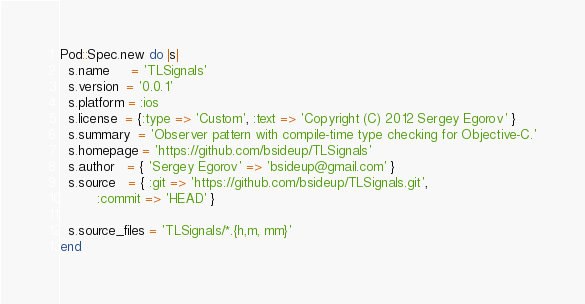<code> <loc_0><loc_0><loc_500><loc_500><_Ruby_>Pod::Spec.new do |s|
  s.name     = 'TLSignals'
  s.version  = '0.0.1'
  s.platform = :ios
  s.license  = {:type => 'Custom', :text => 'Copyright (C) 2012 Sergey Egorov' }
  s.summary  = 'Observer pattern with compile-time type checking for Objective-C.'
  s.homepage = 'https://github.com/bsideup/TLSignals'
  s.author   = { 'Sergey Egorov' => 'bsideup@gmail.com' }
  s.source   = { :git => 'https://github.com/bsideup/TLSignals.git',
		 :commit => 'HEAD' }

  s.source_files = 'TLSignals/*.{h,m, mm}'
end
</code> 